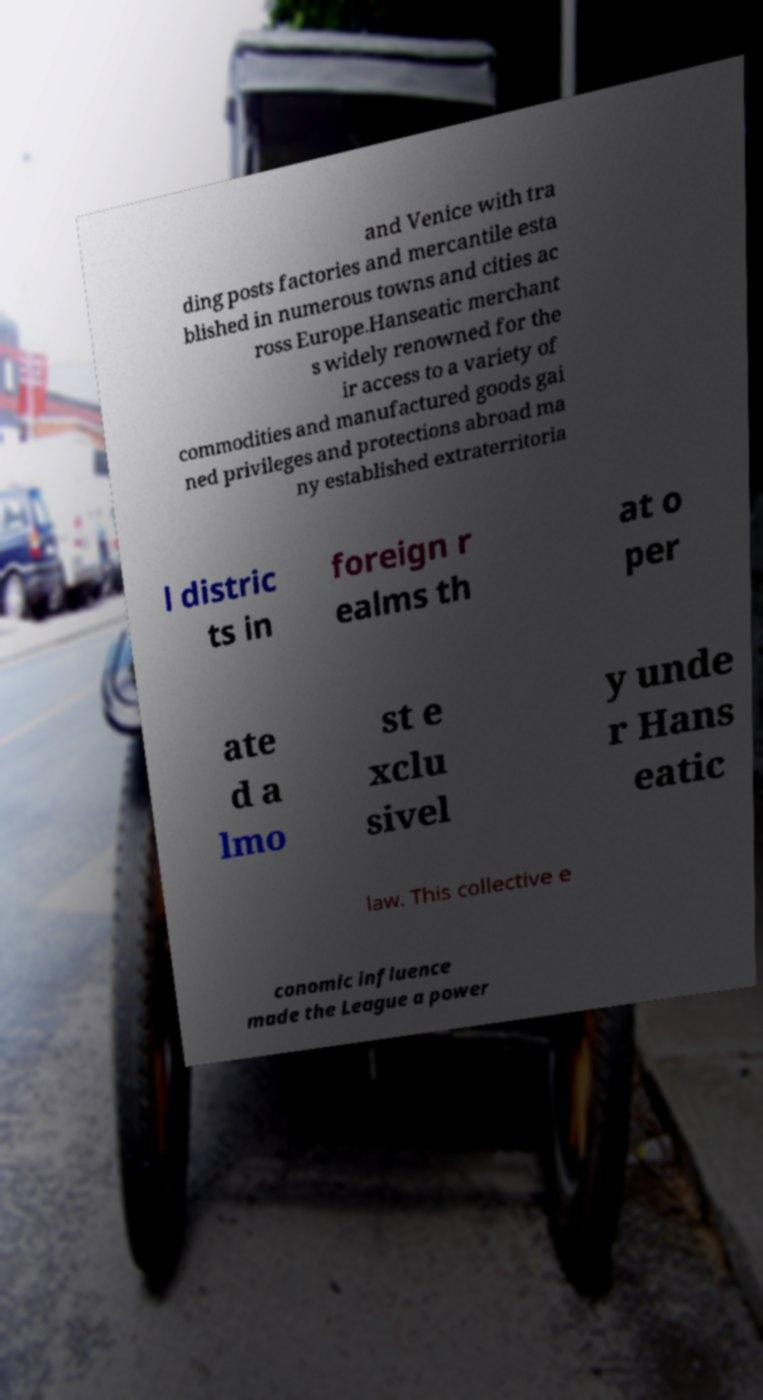For documentation purposes, I need the text within this image transcribed. Could you provide that? and Venice with tra ding posts factories and mercantile esta blished in numerous towns and cities ac ross Europe.Hanseatic merchant s widely renowned for the ir access to a variety of commodities and manufactured goods gai ned privileges and protections abroad ma ny established extraterritoria l distric ts in foreign r ealms th at o per ate d a lmo st e xclu sivel y unde r Hans eatic law. This collective e conomic influence made the League a power 